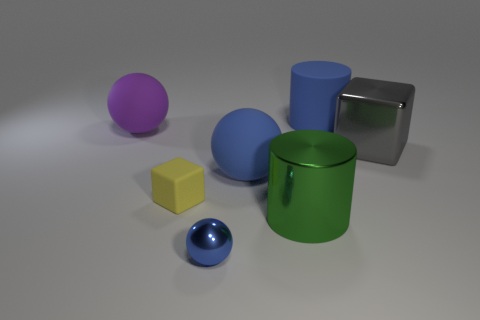Is the blue object in front of the large blue rubber sphere made of the same material as the block left of the matte cylinder?
Provide a succinct answer. No. What number of large matte spheres are the same color as the tiny shiny ball?
Offer a very short reply. 1. There is a blue object that is both on the left side of the blue rubber cylinder and behind the big green metal object; what shape is it?
Give a very brief answer. Sphere. There is a large object that is behind the gray cube and on the left side of the large blue cylinder; what color is it?
Your response must be concise. Purple. Are there more large matte spheres that are to the left of the small yellow rubber object than cylinders that are to the right of the big purple matte thing?
Ensure brevity in your answer.  No. What is the color of the large rubber ball in front of the big gray metal object?
Your answer should be very brief. Blue. There is a big shiny object in front of the small yellow matte block; is its shape the same as the blue object behind the purple rubber object?
Keep it short and to the point. Yes. Is there a matte object that has the same size as the shiny cube?
Offer a very short reply. Yes. There is a big blue object on the left side of the big green metallic thing; what is its material?
Offer a terse response. Rubber. Is the blue ball in front of the green object made of the same material as the large gray object?
Your response must be concise. Yes. 